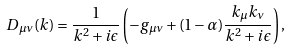<formula> <loc_0><loc_0><loc_500><loc_500>D _ { \mu \nu } ( k ) = \frac { 1 } { k ^ { 2 } + i \epsilon } \left ( - g _ { \mu \nu } + ( 1 - \alpha ) \frac { k _ { \mu } k _ { \nu } } { k ^ { 2 } + i \epsilon } \right ) ,</formula> 